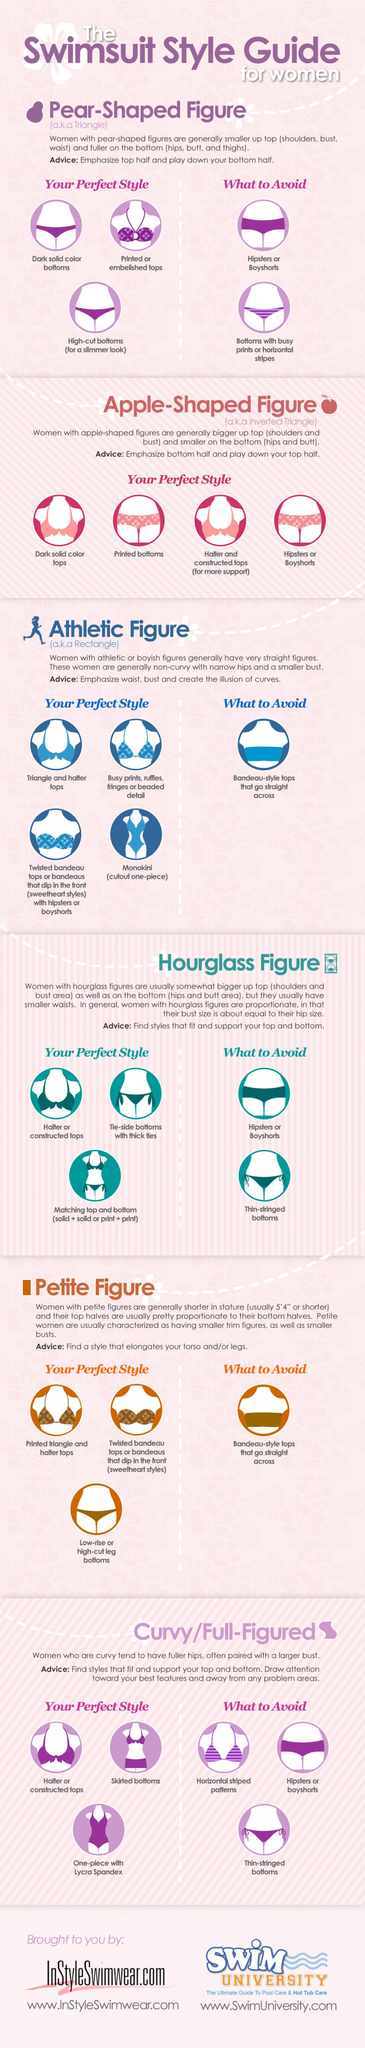Identify some key points in this picture. Women with hourglass or curvy/full-figured figures should avoid wearing thin-stringed bottoms. The figure that is also known as the inverted triangle is the apple-shaped figure. Women with pear-shaped figures should avoid hipsters and bottoms with busy prints or horizontal stripes, as these styles are not flattering to their body shape. The number of figure types mentioned is six. The pear-shaped figure is also known as the triangle figure. 